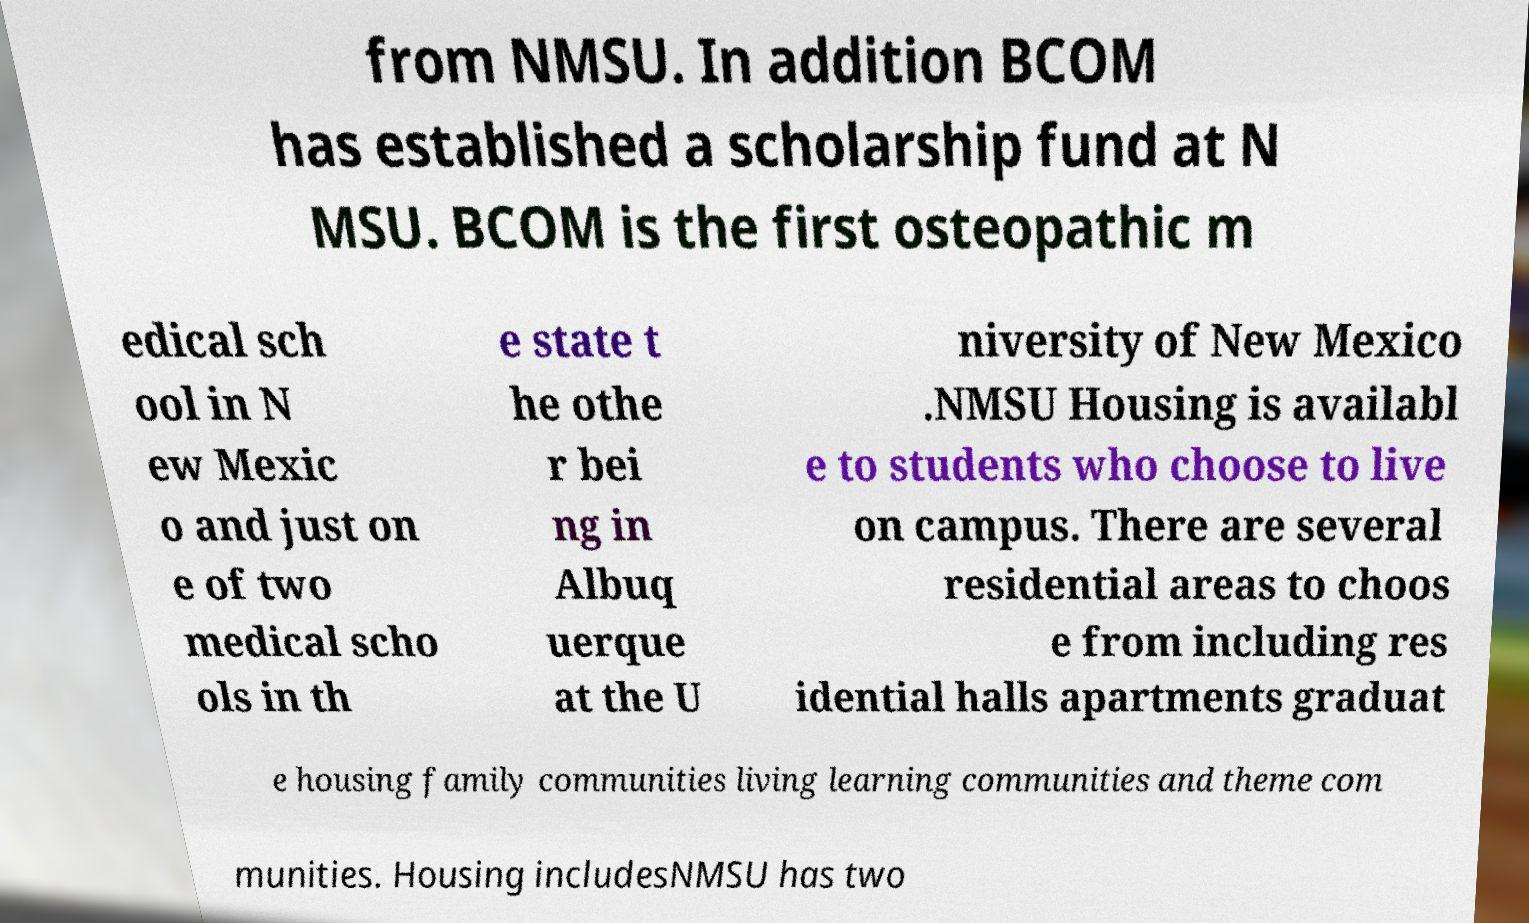There's text embedded in this image that I need extracted. Can you transcribe it verbatim? from NMSU. In addition BCOM has established a scholarship fund at N MSU. BCOM is the first osteopathic m edical sch ool in N ew Mexic o and just on e of two medical scho ols in th e state t he othe r bei ng in Albuq uerque at the U niversity of New Mexico .NMSU Housing is availabl e to students who choose to live on campus. There are several residential areas to choos e from including res idential halls apartments graduat e housing family communities living learning communities and theme com munities. Housing includesNMSU has two 